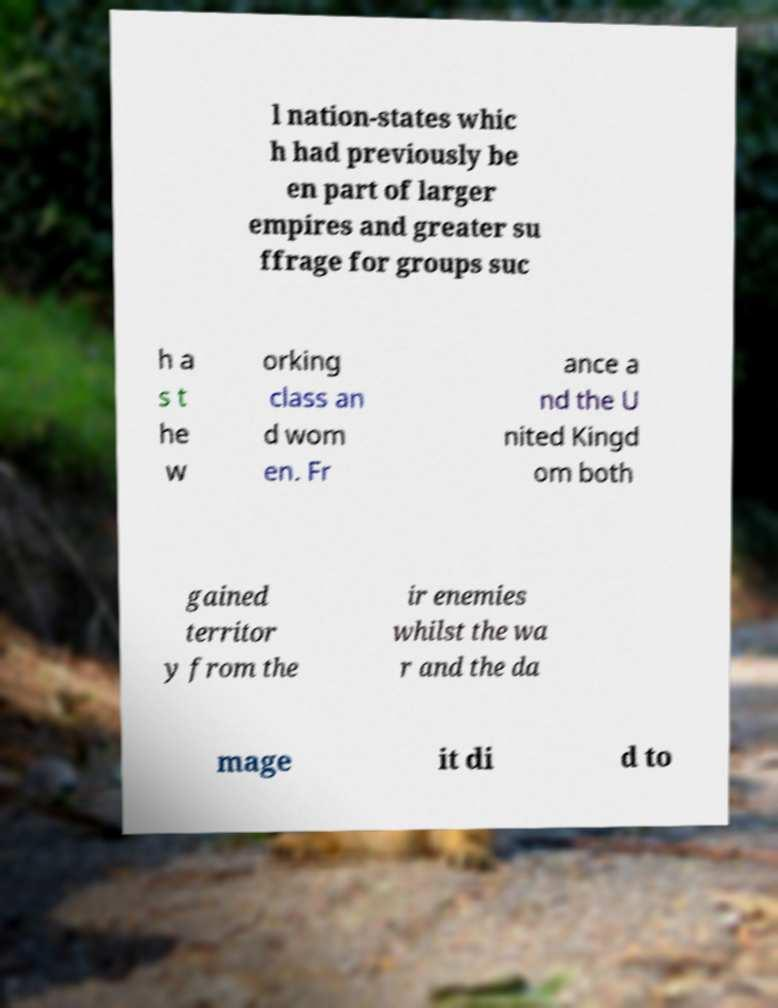Could you extract and type out the text from this image? l nation-states whic h had previously be en part of larger empires and greater su ffrage for groups suc h a s t he w orking class an d wom en. Fr ance a nd the U nited Kingd om both gained territor y from the ir enemies whilst the wa r and the da mage it di d to 